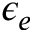Convert formula to latex. <formula><loc_0><loc_0><loc_500><loc_500>\epsilon _ { e }</formula> 